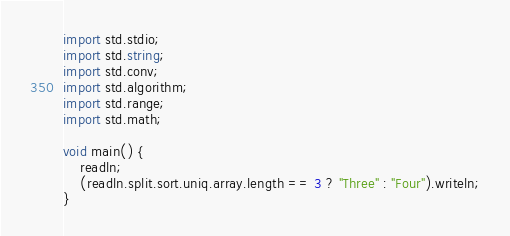Convert code to text. <code><loc_0><loc_0><loc_500><loc_500><_D_>import std.stdio;
import std.string;
import std.conv;
import std.algorithm;
import std.range;
import std.math;

void main() {
	readln;
	(readln.split.sort.uniq.array.length == 3 ? "Three" : "Four").writeln;
}</code> 